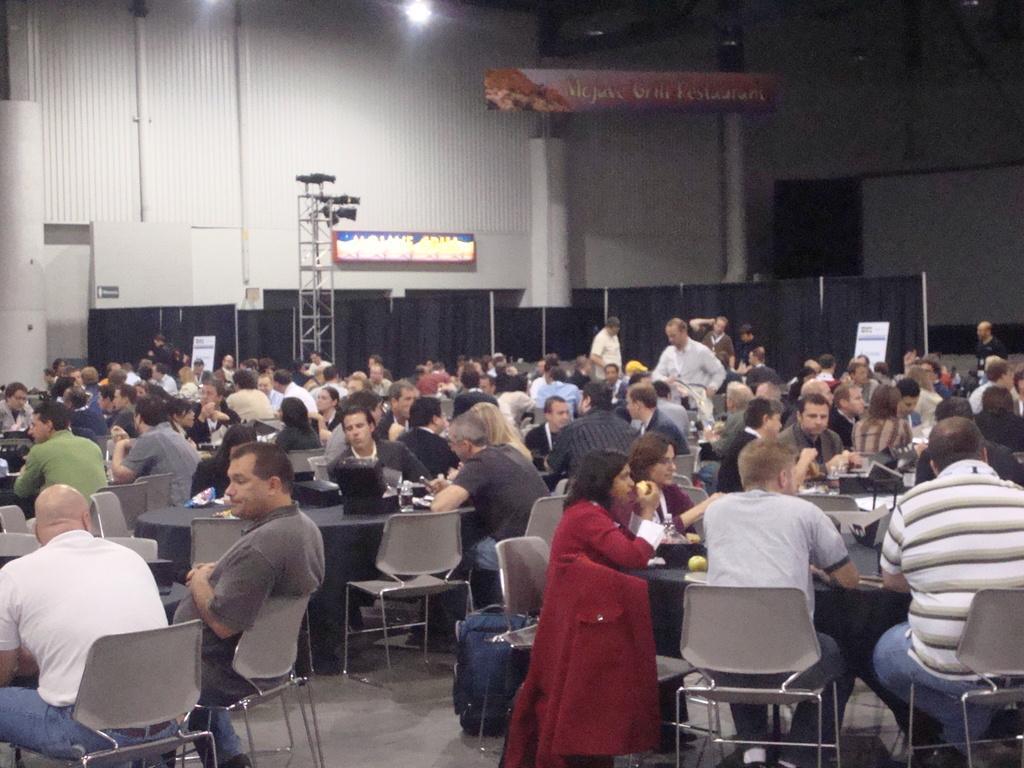In one or two sentences, can you explain what this image depicts? There are many people sitting here on the chair around the table. In the background we can see pole,hoarding,light,pillar and wall. 